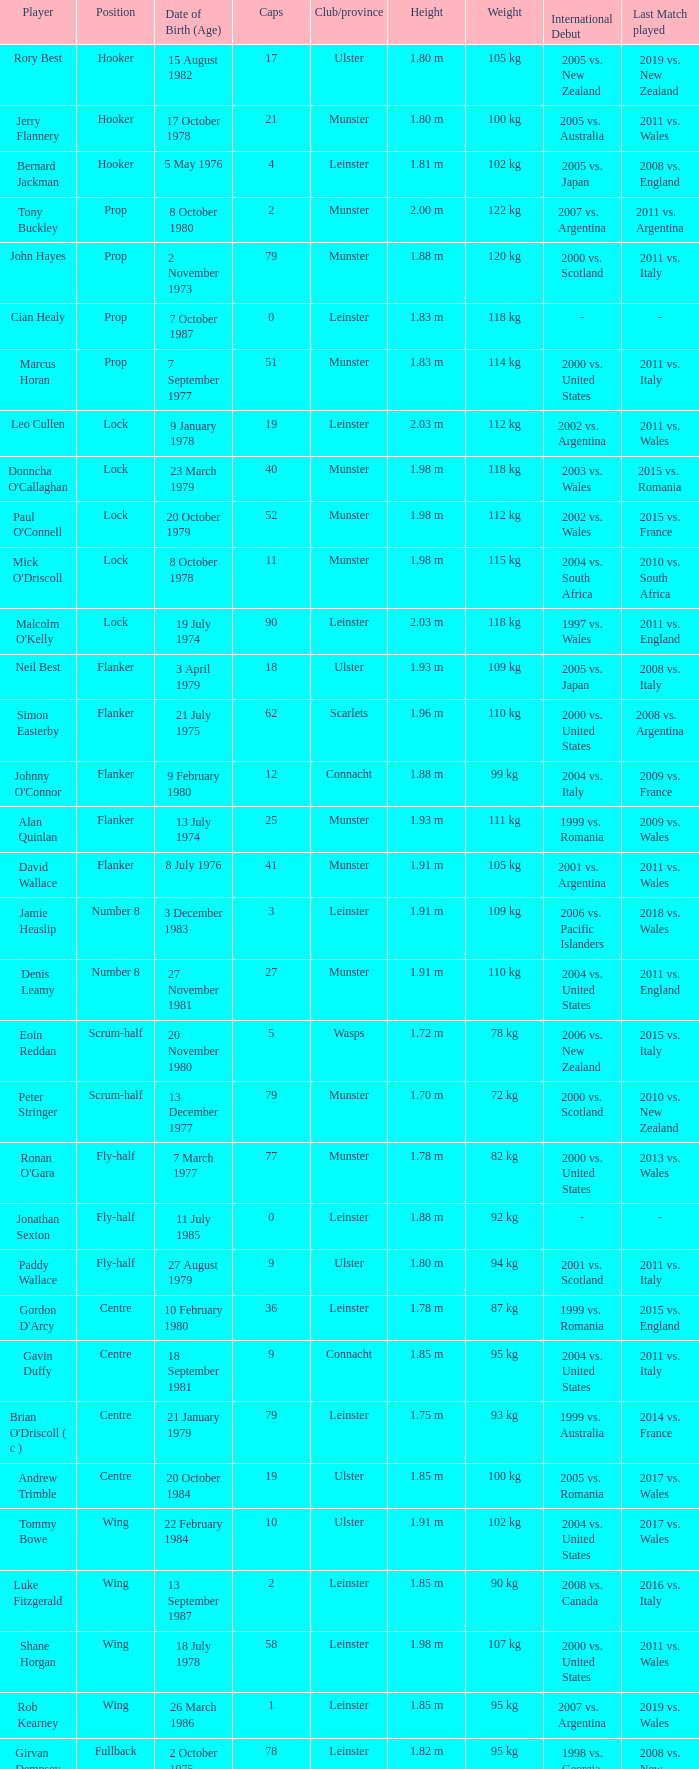Paddy Wallace who plays the position of fly-half has how many Caps? 9.0. 